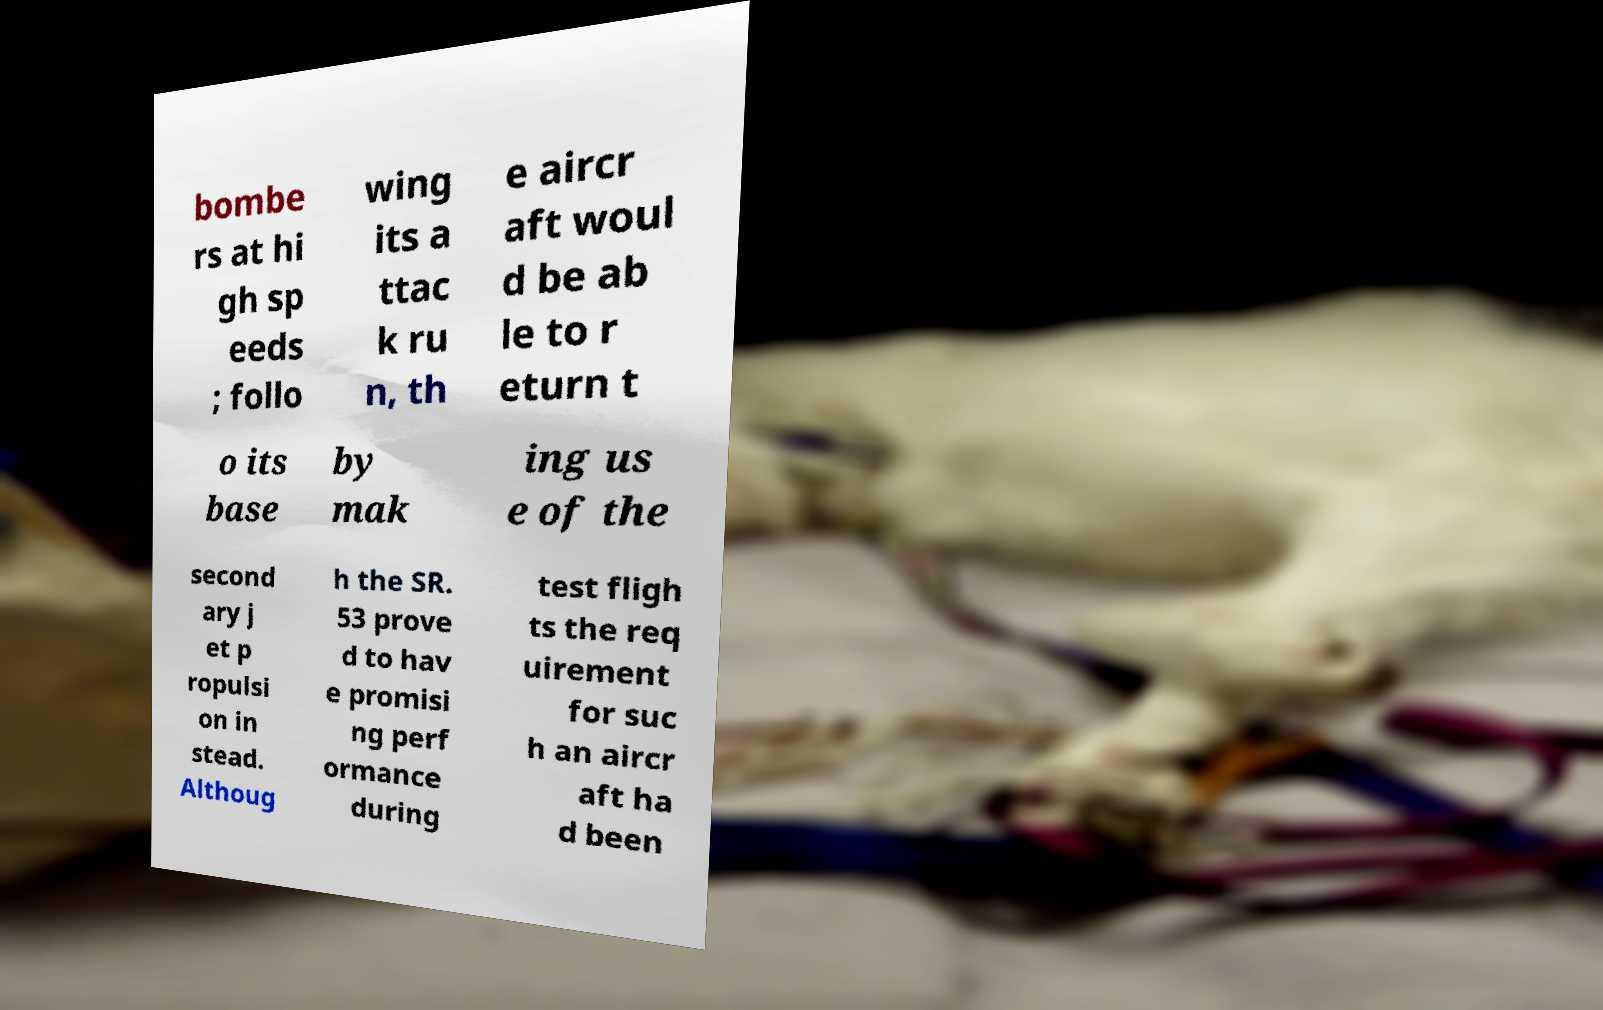I need the written content from this picture converted into text. Can you do that? bombe rs at hi gh sp eeds ; follo wing its a ttac k ru n, th e aircr aft woul d be ab le to r eturn t o its base by mak ing us e of the second ary j et p ropulsi on in stead. Althoug h the SR. 53 prove d to hav e promisi ng perf ormance during test fligh ts the req uirement for suc h an aircr aft ha d been 